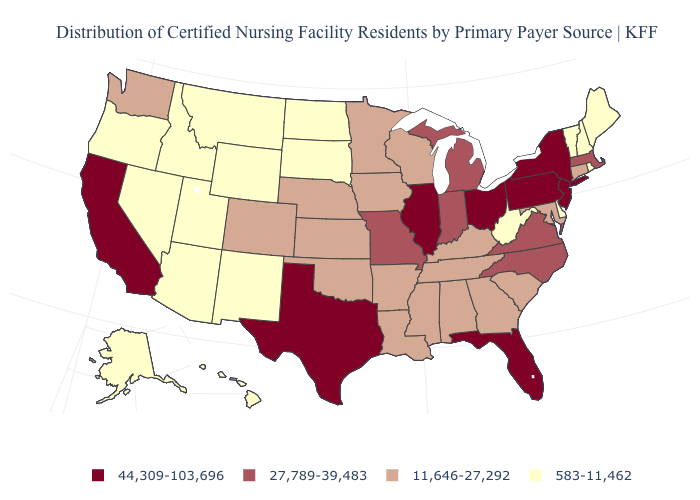What is the highest value in the West ?
Write a very short answer. 44,309-103,696. What is the value of Nebraska?
Keep it brief. 11,646-27,292. What is the value of Louisiana?
Be succinct. 11,646-27,292. Which states hav the highest value in the Northeast?
Answer briefly. New Jersey, New York, Pennsylvania. What is the value of North Dakota?
Keep it brief. 583-11,462. What is the value of North Dakota?
Give a very brief answer. 583-11,462. Among the states that border Arizona , does Utah have the lowest value?
Keep it brief. Yes. Does Ohio have the highest value in the MidWest?
Answer briefly. Yes. Which states hav the highest value in the West?
Be succinct. California. Does the first symbol in the legend represent the smallest category?
Be succinct. No. What is the highest value in states that border South Dakota?
Keep it brief. 11,646-27,292. Among the states that border Pennsylvania , which have the highest value?
Answer briefly. New Jersey, New York, Ohio. What is the highest value in the South ?
Keep it brief. 44,309-103,696. Which states have the lowest value in the MidWest?
Be succinct. North Dakota, South Dakota. 